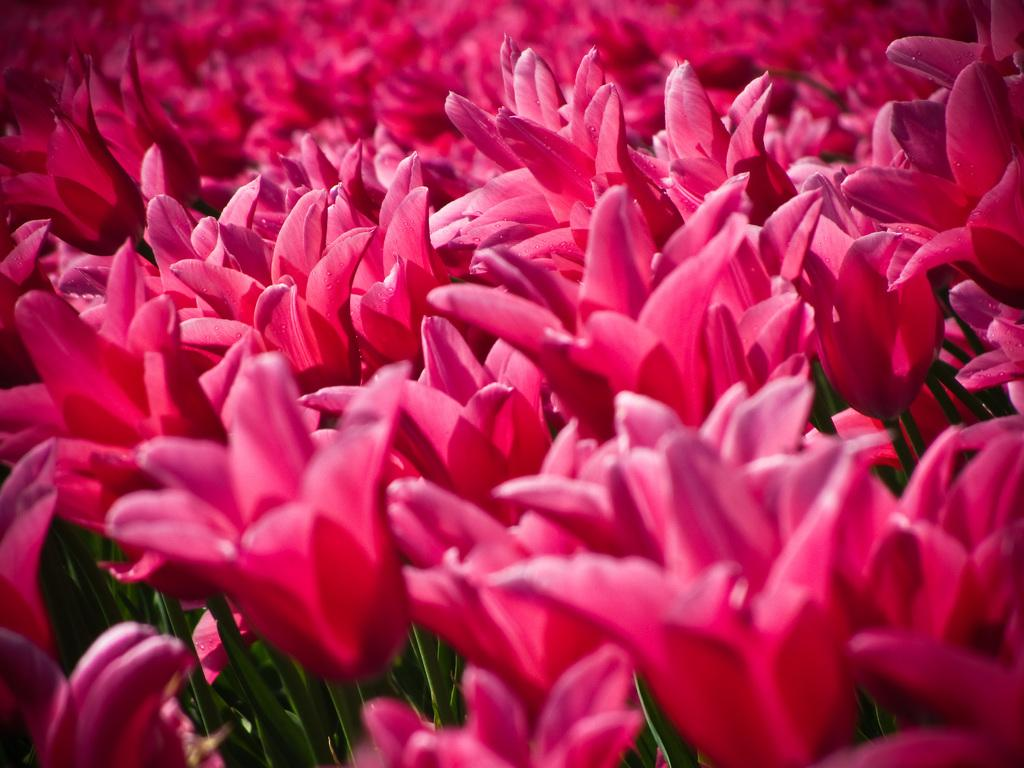What type of living organisms can be seen in the image? There are flowers in the image. What type of quilt is being used to cover the flowers in the image? There is no quilt present in the image; it only features flowers. Is there any indication of a battle taking place in the image? No, there is no indication of a battle or any conflict in the image. 